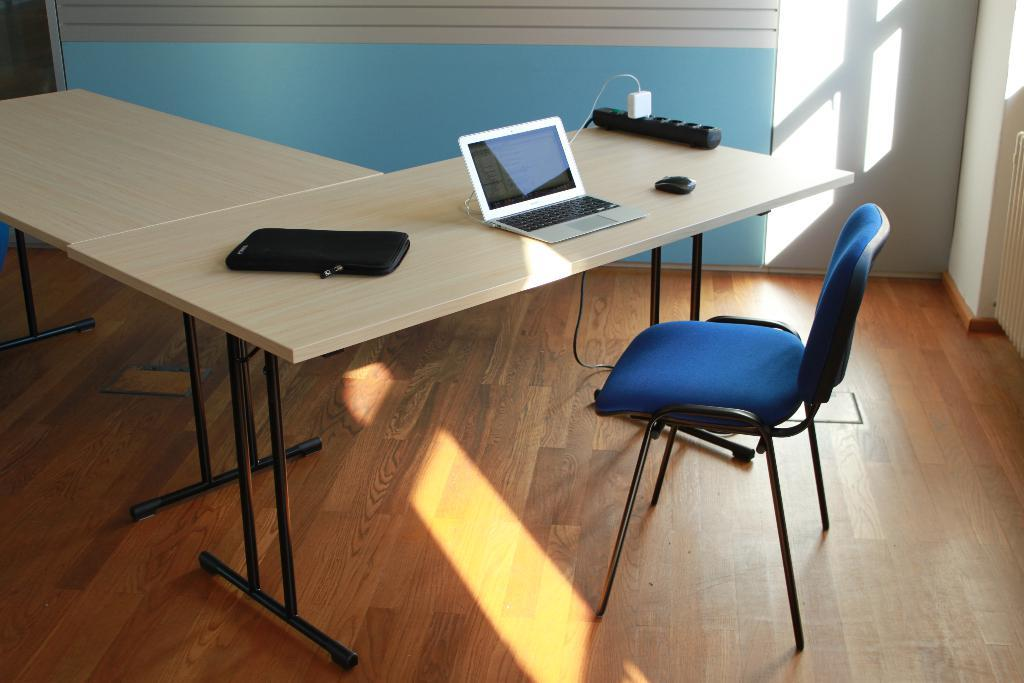What piece of furniture is present in the image? There is a table in the image. What electronic devices are on the table? There is a cell phone and a laptop on the table. What accessory is present for the laptop? There is a laptop cover on the table. What input device is on the table? There is a mouse on the table. What electrical component is on the table? There is a plug in an extension board on the table. What type of seating is visible in the image? There is a chair in the image. What type of structure is visible in the image? There are walls visible in the image. How many zippers are on the laptop cover in the image? There are no zippers present on the laptop cover in the image. What type of tool is being used to tighten the screws on the chair in the image? There are no tools visible in the image, and the chair does not appear to have any screws that need tightening. 